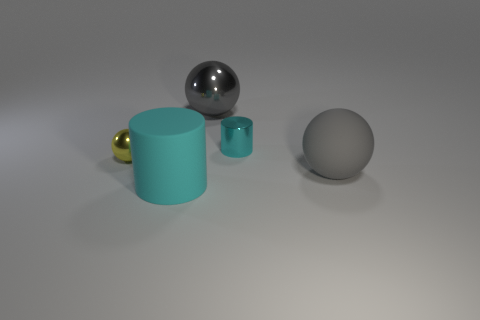Subtract all blue cylinders. How many gray spheres are left? 2 Subtract 1 spheres. How many spheres are left? 2 Add 4 big gray shiny spheres. How many objects exist? 9 Subtract all balls. How many objects are left? 2 Subtract 0 red cylinders. How many objects are left? 5 Subtract all yellow shiny things. Subtract all matte cylinders. How many objects are left? 3 Add 2 gray spheres. How many gray spheres are left? 4 Add 2 big cyan metallic objects. How many big cyan metallic objects exist? 2 